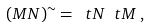<formula> <loc_0><loc_0><loc_500><loc_500>( M N ) ^ { \sim } = \ t N \ t M \, ,</formula> 